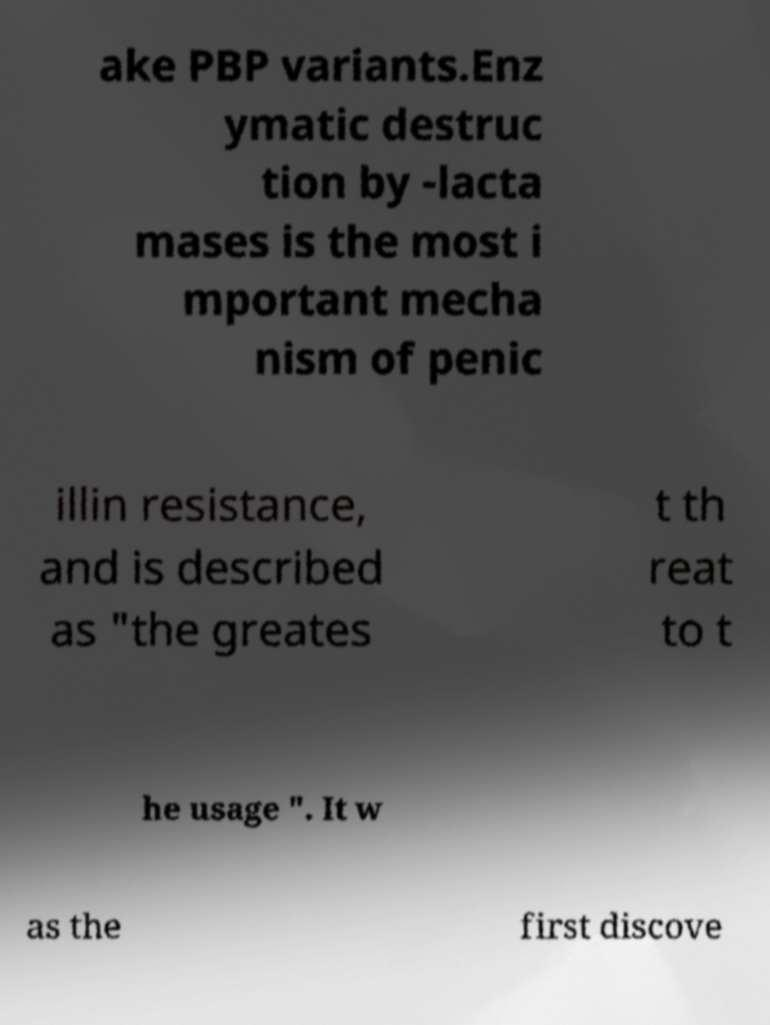Could you assist in decoding the text presented in this image and type it out clearly? ake PBP variants.Enz ymatic destruc tion by -lacta mases is the most i mportant mecha nism of penic illin resistance, and is described as "the greates t th reat to t he usage ". It w as the first discove 